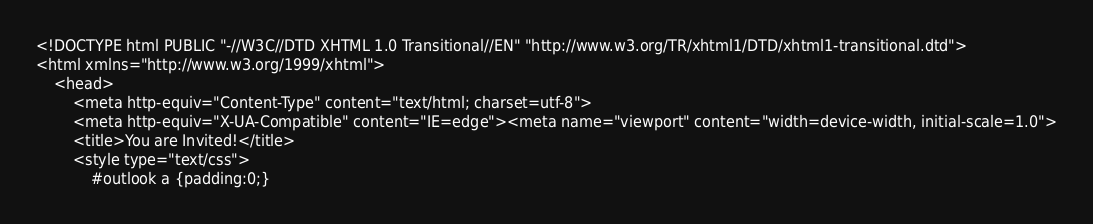Convert code to text. <code><loc_0><loc_0><loc_500><loc_500><_PHP_><!DOCTYPE html PUBLIC "-//W3C//DTD XHTML 1.0 Transitional//EN" "http://www.w3.org/TR/xhtml1/DTD/xhtml1-transitional.dtd">
<html xmlns="http://www.w3.org/1999/xhtml">
    <head>
        <meta http-equiv="Content-Type" content="text/html; charset=utf-8">
        <meta http-equiv="X-UA-Compatible" content="IE=edge"><meta name="viewport" content="width=device-width, initial-scale=1.0">
        <title>You are Invited!</title>
        <style type="text/css">
            #outlook a {padding:0;}</code> 